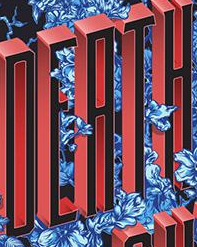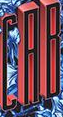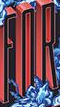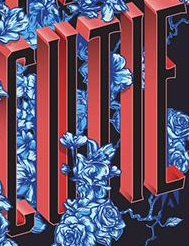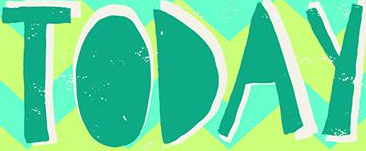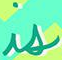Identify the words shown in these images in order, separated by a semicolon. DEATH; CAB; FOR; CUTIE; TODAY; is 